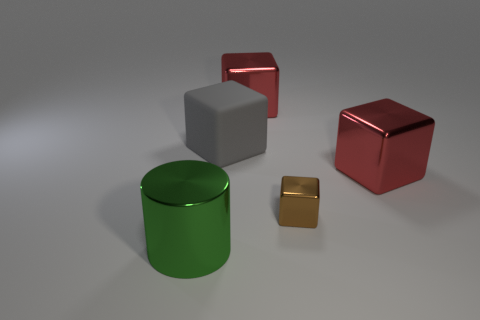Is the number of red things behind the big metallic cylinder greater than the number of tiny purple metal blocks? yes 